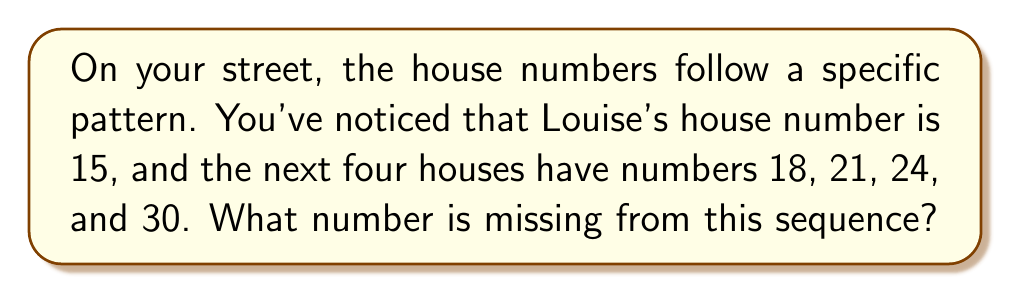Give your solution to this math problem. Let's approach this step-by-step:

1) First, let's write out the sequence we know:
   15, 18, 21, 24, _, 30

2) To find the pattern, let's calculate the differences between each pair of consecutive numbers:
   18 - 15 = 3
   21 - 18 = 3
   24 - 21 = 3
   30 - 24 = 6

3) We notice that the difference is consistently 3, except for the last pair where it's 6.

4) This suggests that there's a missing number between 24 and 30.

5) If we add 3 to 24 (following the pattern), we get:
   24 + 3 = 27

6) Let's verify:
   27 - 24 = 3 (matches the pattern)
   30 - 27 = 3 (now this matches too)

7) The complete sequence is:
   15, 18, 21, 24, 27, 30

8) Each term can be represented by the formula:
   $a_n = 15 + 3(n-1)$, where $n$ is the position in the sequence (starting from 1).

Therefore, the missing number in the sequence is 27.
Answer: 27 